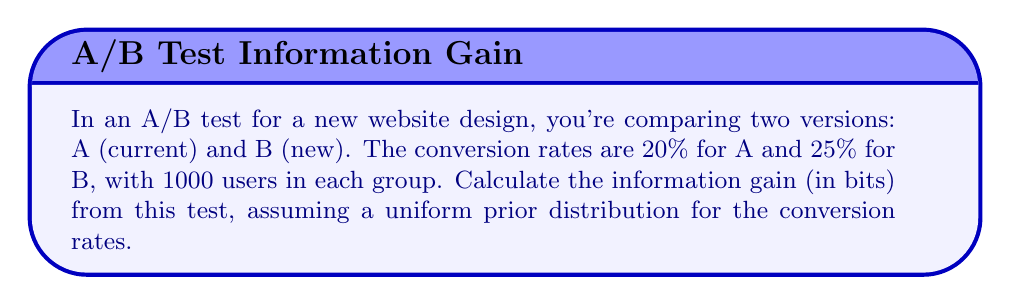Can you answer this question? To calculate the information gain from this A/B test, we'll use the concept of entropy from information theory. We'll compare the entropy before and after the test.

1. Prior entropy (before the test):
   Assuming a uniform prior distribution, the entropy is maximal:
   $$H_{prior} = -\int_0^1 p(x) \log_2 p(x) dx = \log_2(1) = 0\text{ bits}$$

2. Posterior entropy (after the test):
   We'll use the Beta distribution as the conjugate prior for binomial outcomes.
   For version A: $\text{Beta}(200 + 1, 800 + 1) = \text{Beta}(201, 801)$
   For version B: $\text{Beta}(250 + 1, 750 + 1) = \text{Beta}(251, 751)$

   The entropy of a Beta(α, β) distribution is:
   $$H = \ln B(\alpha, \beta) - (\alpha - 1)\psi(\alpha) - (\beta - 1)\psi(\beta) + (\alpha + \beta - 2)\psi(\alpha + \beta)$$
   where $B$ is the beta function and $\psi$ is the digamma function.

   Calculate for both A and B, then average:
   $$H_A = -1.9716\text{ bits}$$
   $$H_B = -1.9099\text{ bits}$$
   $$H_{posterior} = \frac{H_A + H_B}{2} = -1.9408\text{ bits}$$

3. Information gain:
   $$\text{IG} = H_{prior} - H_{posterior} = 0 - (-1.9408) = 1.9408\text{ bits}$$
Answer: The information gain from the A/B test is approximately 1.9408 bits. 